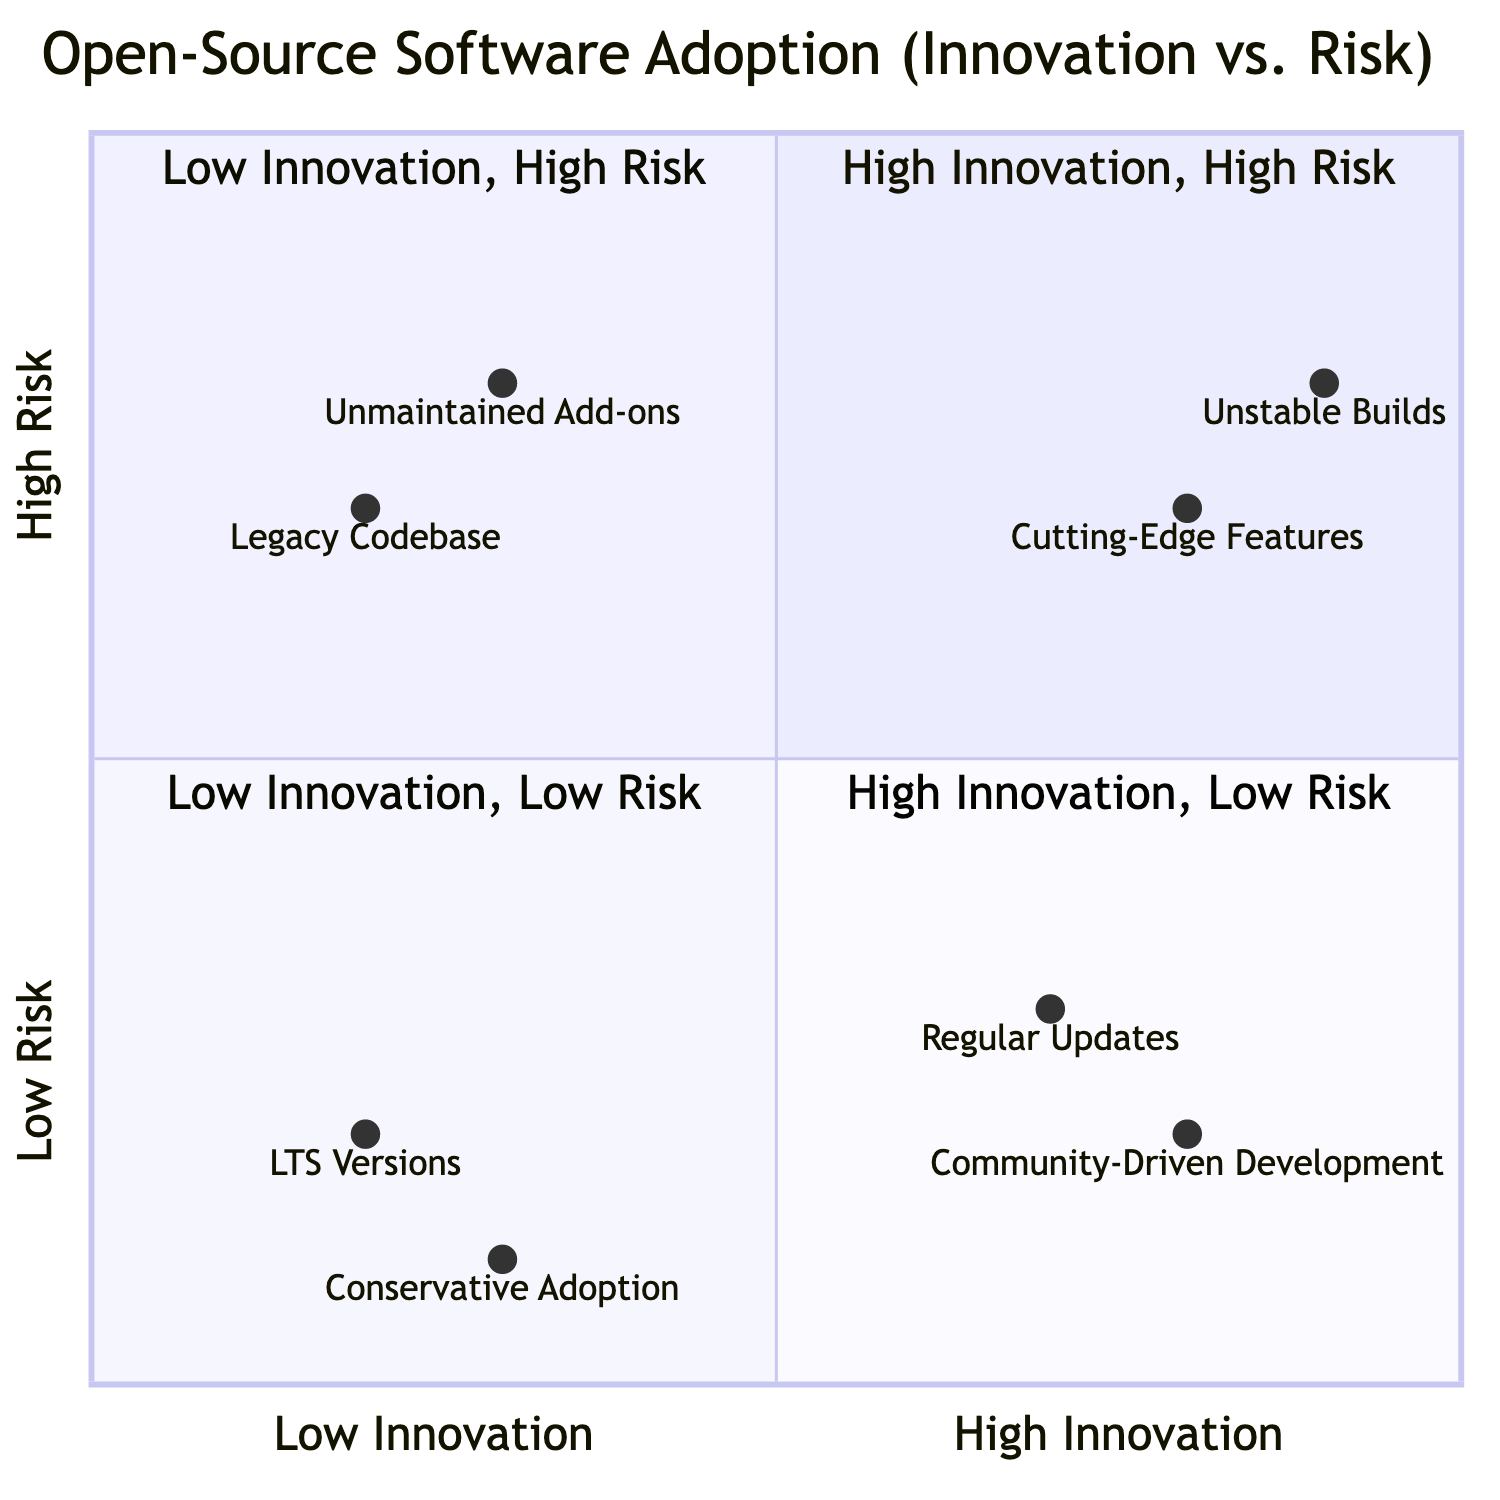What are the names of the two items in the "High Innovation, High Risk" quadrant? The "High Innovation, High Risk" quadrant has two items: "Cutting-Edge Features" and "Unstable Builds." These names are listed directly in that quadrant of the diagram.
Answer: Cutting-Edge Features, Unstable Builds Which item has the lowest innovation according to the diagram? The item with the lowest innovation is "LTS Versions", found in the "Low Innovation, Low Risk" quadrant, which has the coordinates [0.2, 0.2], indicating low innovation.
Answer: LTS Versions How many items are in the "Low Innovation, High Risk" quadrant? The "Low Innovation, High Risk" quadrant contains two items: "Legacy Codebase" and "Unmaintained Add-ons". The count can be confirmed visually from that quadrant.
Answer: 2 Which item has a higher risk: "Regular Updates" or "Community-Driven Development"? "Regular Updates," positioned at [0.7, 0.3], has a risk value of 0.3, whereas "Community-Driven Development," positioned at [0.8, 0.2], has a risk value of 0.2. Comparing these values shows "Regular Updates" has a higher risk.
Answer: Regular Updates What is the relationship between "LTS Versions" and "Conservative Adoption"? Both "LTS Versions" and "Conservative Adoption" are located in the "Low Innovation, Low Risk" quadrant. Specifically, "LTS Versions" is at [0.2, 0.2], while "Conservative Adoption" is at [0.3, 0.1], indicating that they share the same innovation and risk level category.
Answer: Both are in Low Innovation, Low Risk quadrant Which quadrant contains the item "Firefox Quantum"? "Firefox Quantum" is categorized under "Cutting-Edge Features," which is found in the "High Innovation, High Risk" quadrant according to the provided relationships in the diagram.
Answer: High Innovation, High Risk What is the description of "Unstable Builds"? The description for "Unstable Builds" is "Beta or nightly builds that may have new but untested features," as indicated in the corresponding quadrant section of the diagram.
Answer: Beta or nightly builds that may have new but untested features How many items are classified under "High Innovation"? There are four items classified under "High Innovation," which are located in the "High Innovation, High Risk" and "High Innovation, Low Risk" quadrants. These include "Cutting-Edge Features," "Unstable Builds," "Regular Updates," and "Community-Driven Development," making a total of four items.
Answer: 4 